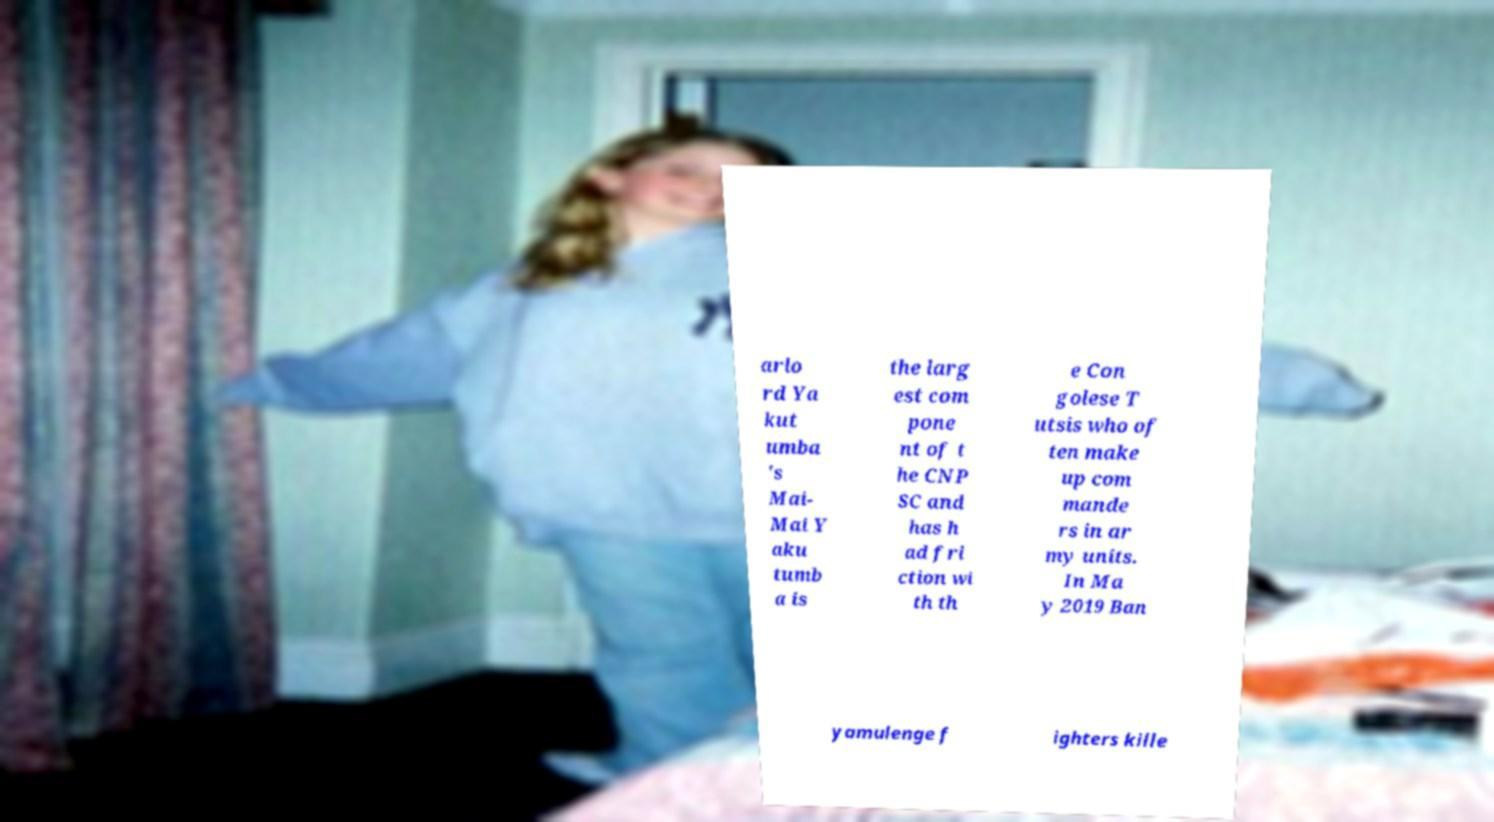Can you accurately transcribe the text from the provided image for me? arlo rd Ya kut umba 's Mai- Mai Y aku tumb a is the larg est com pone nt of t he CNP SC and has h ad fri ction wi th th e Con golese T utsis who of ten make up com mande rs in ar my units. In Ma y 2019 Ban yamulenge f ighters kille 